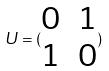Convert formula to latex. <formula><loc_0><loc_0><loc_500><loc_500>U = ( \begin{matrix} 0 & 1 \\ 1 & 0 \end{matrix} )</formula> 